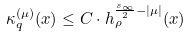<formula> <loc_0><loc_0><loc_500><loc_500>\kappa _ { q } ^ { ( \mu ) } ( x ) \leq C \cdot h _ { \rho } ^ { \frac { s _ { \infty } } { 2 } - | \mu | } ( x )</formula> 